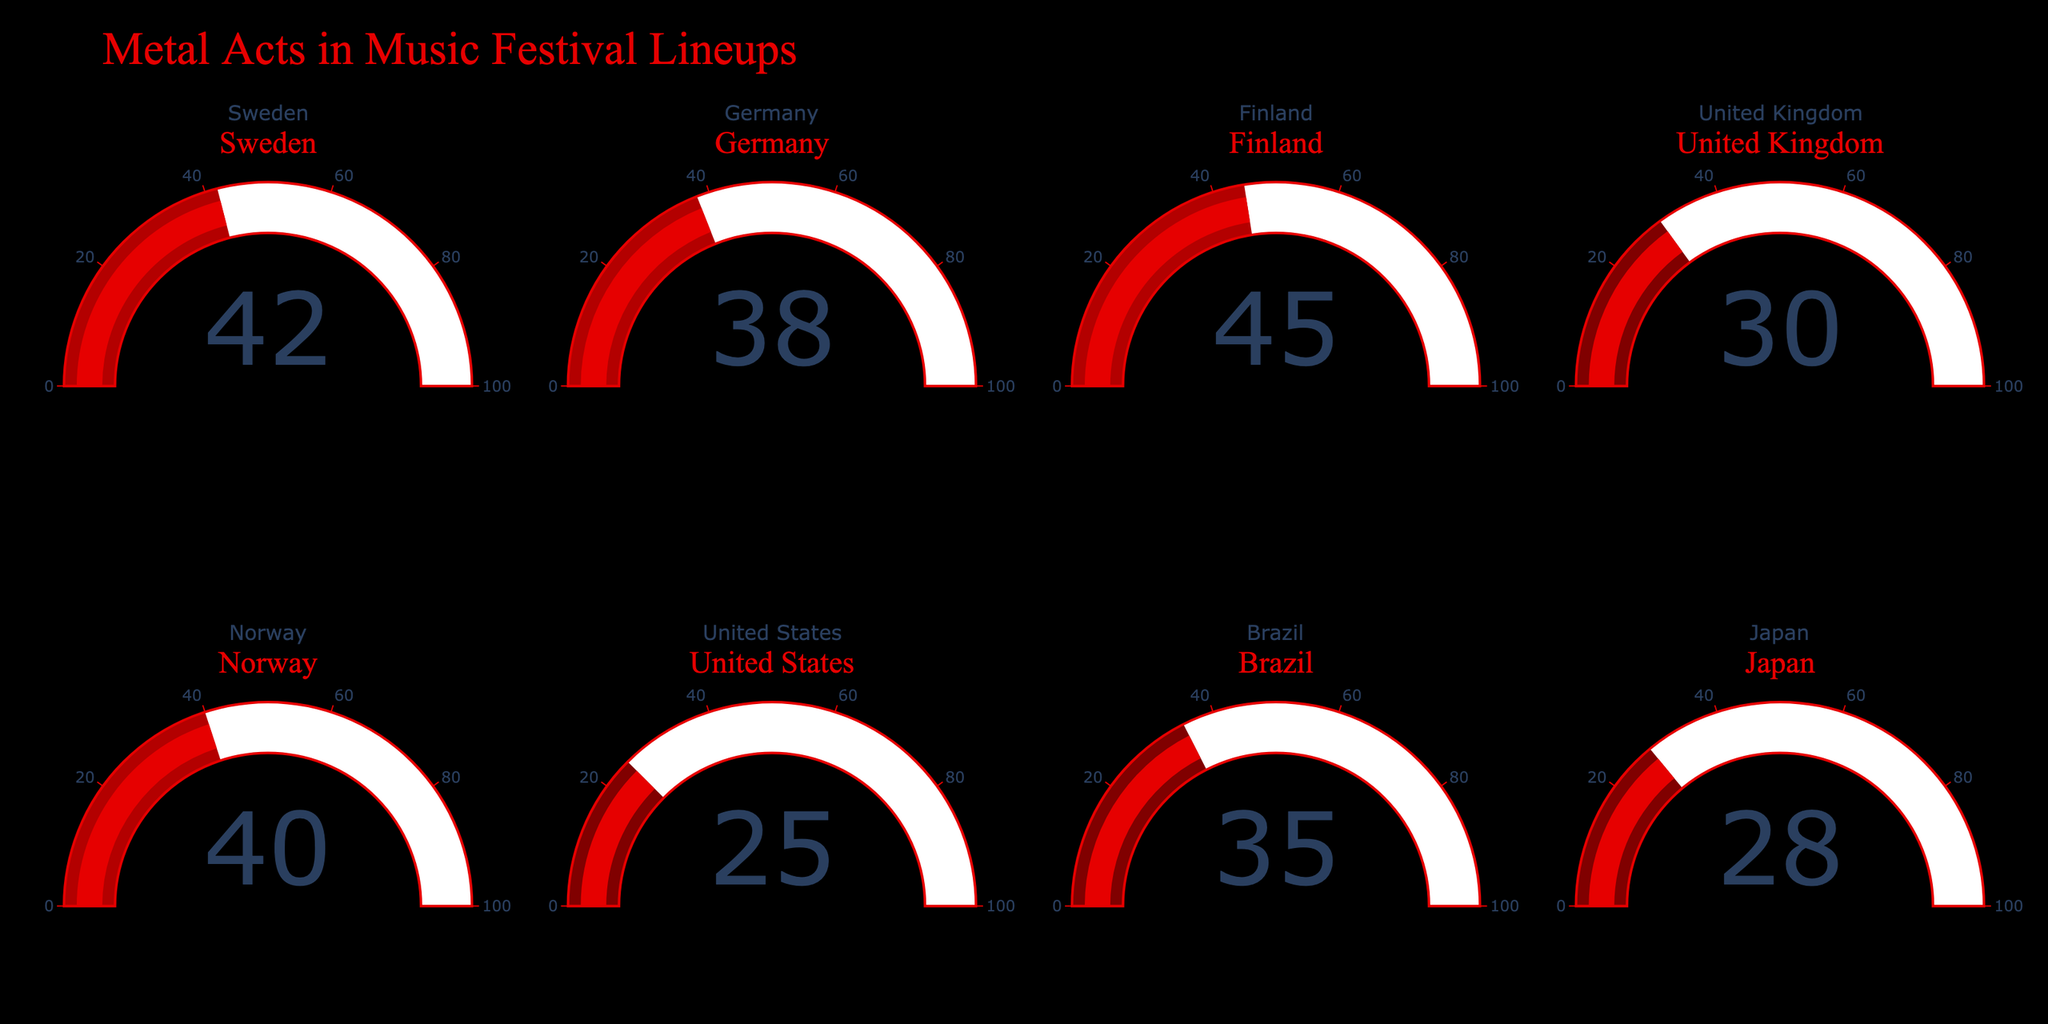What is the title of the figure? The title of the figure is centered at the top and is displayed in a large font size. It reads "Metal Acts in Music Festival Lineups".
Answer: Metal Acts in Music Festival Lineups What is the percentage of music festival lineups featuring metal acts in Finland? The gauge for Finland is in the top row, third column, and displays the percentage value within the gauge. It shows 45%.
Answer: 45% Which country has the lowest percentage of music festival lineups featuring metal acts? Looking at all the gauges, the United States has the smallest percentage value, which is 25%.
Answer: United States What is the sum of the percentages for Sweden and Germany? The gauge for Sweden shows 42% and the gauge for Germany shows 38%. Summing these percentages, we get 42 + 38 = 80.
Answer: 80% Which country has a higher percentage of metal acts in festival lineups, Norway or Japan? By comparing the gauge values, Norway shows 40% while Japan shows 28%. Therefore, Norway has a higher percentage.
Answer: Norway How many countries have a percentage of 40% or more for metal acts in festival lineups? Observing the gauge values, the countries with 40% or more are Sweden (42%), Finland (45%), and Norway (40%). That's a total of 3 countries.
Answer: 3 What is the median percentage value of all the countries' metal act lineups? First, we list all the percentages: 42, 38, 45, 30, 40, 25, 35, 28. Sorting these values: 25, 28, 30, 35, 38, 40, 42, 45. The median value is the average of the 4th and 5th values, (35 + 38) / 2 = 36.5.
Answer: 36.5 Which two countries have the same tens digit in their percentage values, and what is that digit? Examining the percentages, Sweden, and Norway both have a value in the 40s (42 and 40 respectively). Therefore, the tens digit is 4.
Answer: Sweden and Norway, 4 What is the range of percentage values shown in the gauges? The highest percentage is 45% (Finland) and the lowest is 25% (United States). The range is calculated as 45 - 25 = 20.
Answer: 20 What color represents the highest percentage range on the gauges? The highest percentage is 45% and the color coding shows that higher percentages are assigned a deep red color. This is the '#ff8080' step used for the 37.5% to 50% range.
Answer: Deep red (around '#ff8080') 